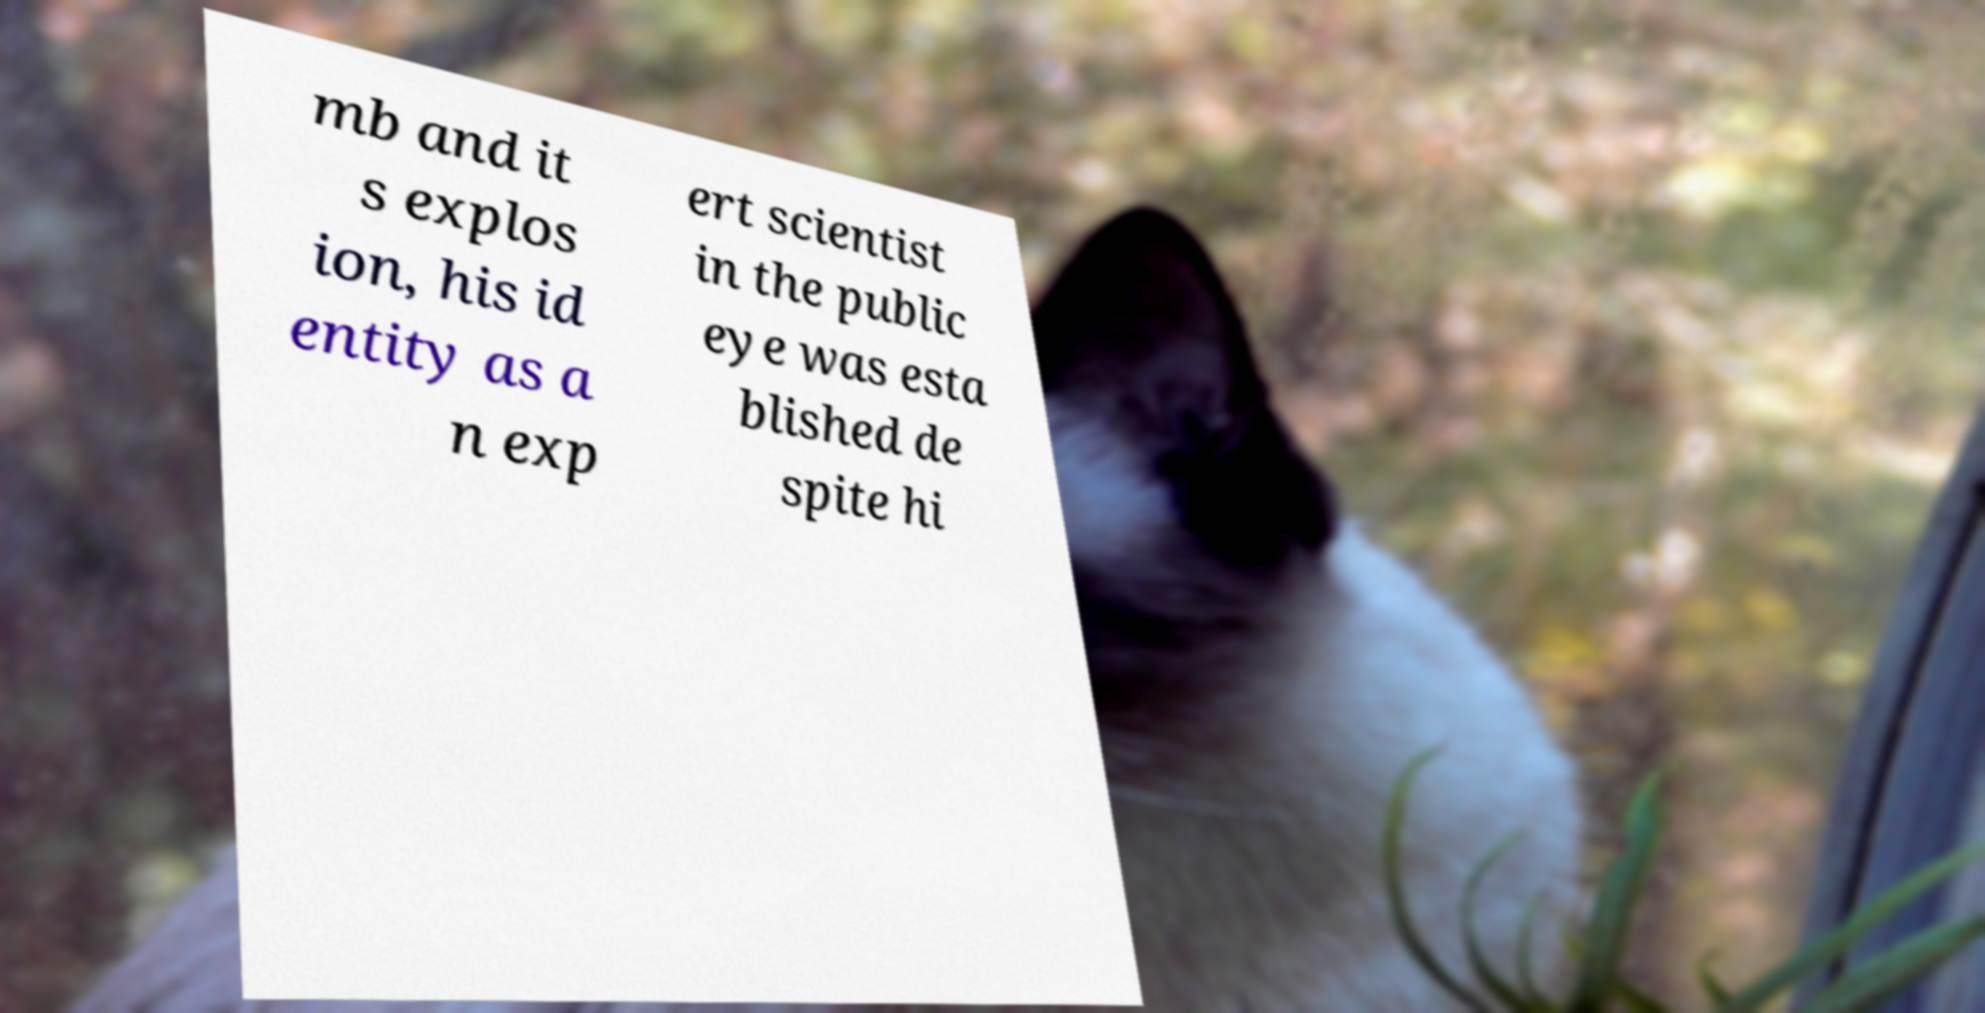For documentation purposes, I need the text within this image transcribed. Could you provide that? mb and it s explos ion, his id entity as a n exp ert scientist in the public eye was esta blished de spite hi 